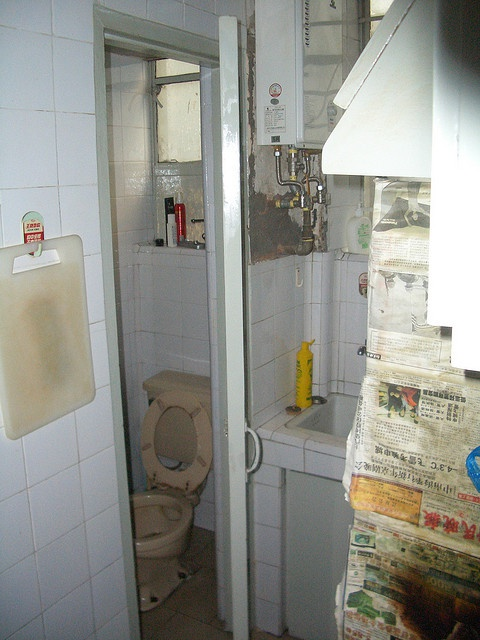Describe the objects in this image and their specific colors. I can see toilet in gray and black tones, sink in gray and lightgray tones, bottle in gray, olive, and darkgray tones, bottle in gray, maroon, black, and darkgray tones, and bottle in gray and black tones in this image. 